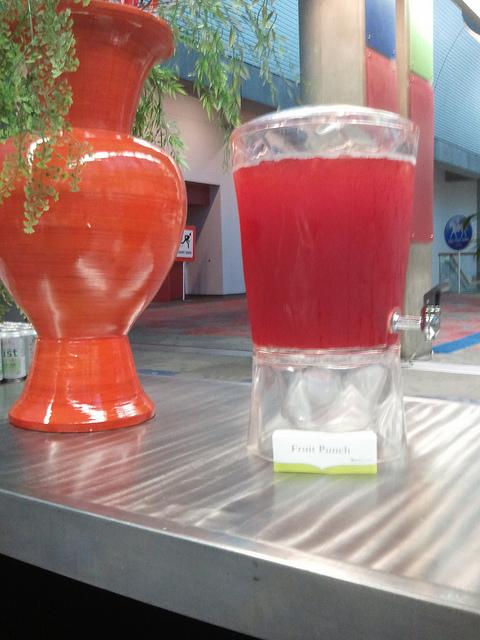What type of station is this? Please explain your reasoning. beverage. It is a place to get drinks. 